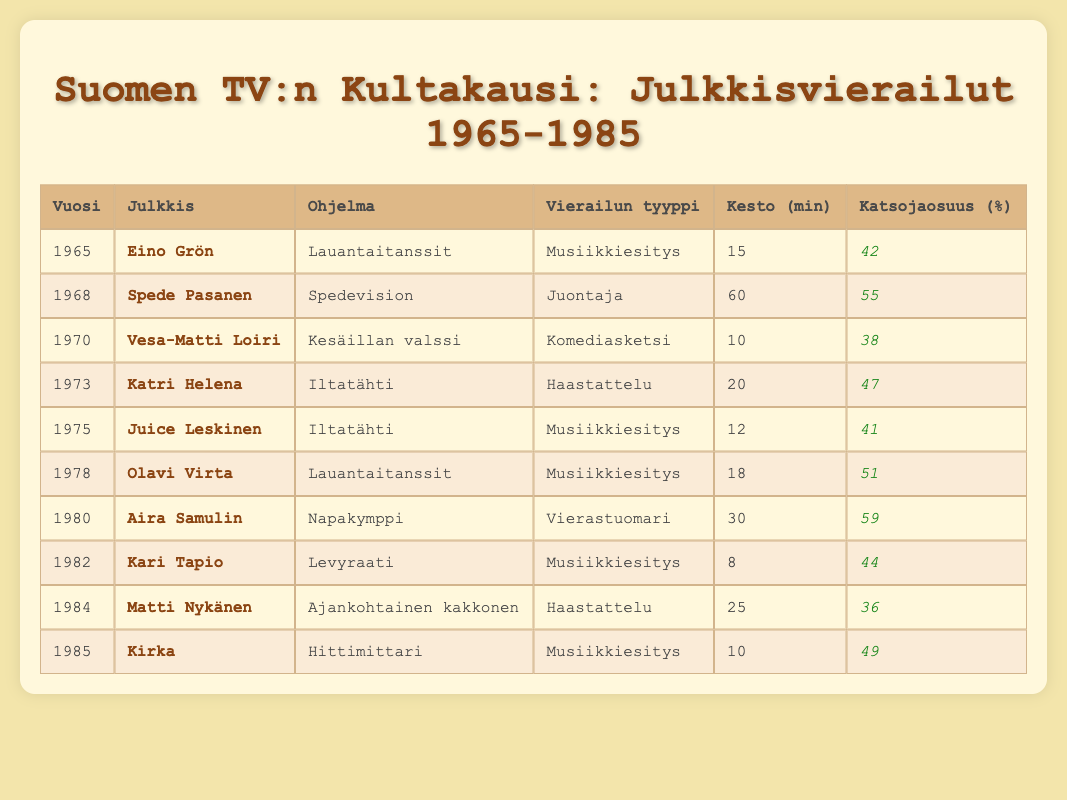What was the highest viewer rating for a guest appearance in the table? The table lists viewer ratings for each guest appearance. By scanning through the "Katsojaosuus (%)" column, the highest value is 59%, associated with Aira Samulin on Napakymppi in 1980.
Answer: 59% Which celebrity made a musical performance appearance in Lauantaitanssit? Referring to the table, Eino Grön appeared in Lauantaitanssit in 1965, performing musically. Additionally, Olavi Virta performed musically in the same show in 1978.
Answer: Eino Grön and Olavi Virta How many total minutes did Juice Leskinen appear in Iltatähti? Juice Leskinen's guest appearance in Iltatähti is recorded as lasting 12 minutes. There are no other appearances listed for him in this show, so the total is simply 12 minutes.
Answer: 12 minutes Was there any guest appearance in the table that lasted less than 10 minutes? The table shows all guest appearances and their corresponding durations. Scanning through the "Kesto (min)" column reveals no appearances lasting less than 10 minutes, confirming that no such appearances are listed.
Answer: No What was the average viewer rating of all the appearances in the table? To find the average viewer rating, first add all the ratings: 42 + 55 + 38 + 47 + 41 + 51 + 59 + 44 + 36 + 49 = 462. Then divide by the number of appearances (10), yielding an average rating of 46.2%.
Answer: 46.2% 